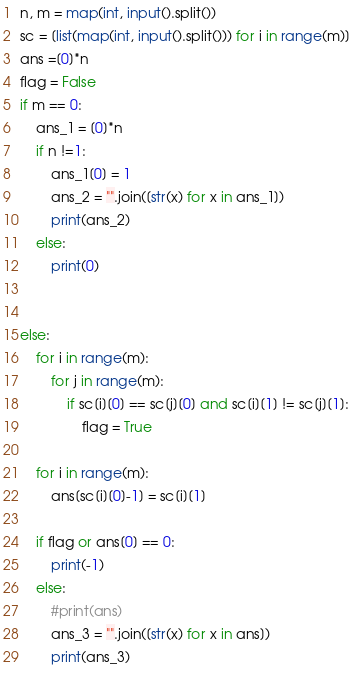Convert code to text. <code><loc_0><loc_0><loc_500><loc_500><_Python_>n, m = map(int, input().split())
sc = [list(map(int, input().split())) for i in range(m)]
ans =[0]*n
flag = False
if m == 0:
    ans_1 = [0]*n
    if n !=1:
        ans_1[0] = 1
        ans_2 = "".join([str(x) for x in ans_1])
        print(ans_2)
    else:
        print(0)


else:
    for i in range(m):
        for j in range(m):
            if sc[i][0] == sc[j][0] and sc[i][1] != sc[j][1]:
                flag = True

    for i in range(m):
        ans[sc[i][0]-1] = sc[i][1]

    if flag or ans[0] == 0:
        print(-1)
    else:
        #print(ans)
        ans_3 = "".join([str(x) for x in ans])
        print(ans_3)</code> 